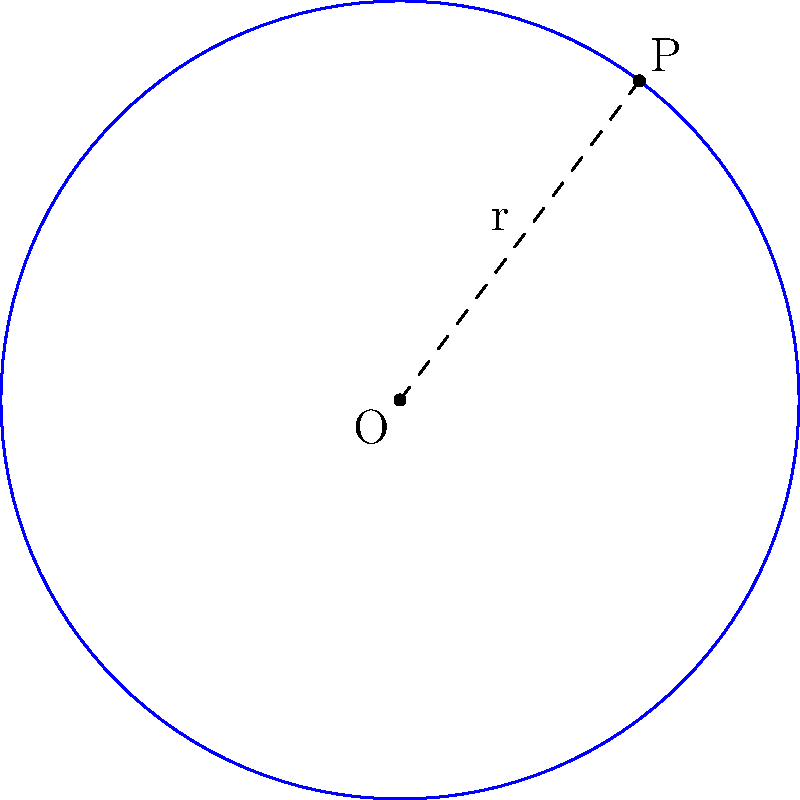Instead of wasting time watching TV series, consider this mathematical challenge: A circle has its center at point O(2,3) and passes through point P(5,7). Determine the equation of this circle. To find the equation of the circle, we'll follow these steps:

1) The general equation of a circle is $$(x-h)^2 + (y-k)^2 = r^2$$
   where (h,k) is the center and r is the radius.

2) We're given the center O(2,3), so h=2 and k=3.

3) To find r, we need to calculate the distance between O and P:
   $$r = \sqrt{(x_P-x_O)^2 + (y_P-y_O)^2}$$
   $$r = \sqrt{(5-2)^2 + (7-3)^2}$$
   $$r = \sqrt{3^2 + 4^2} = \sqrt{9 + 16} = \sqrt{25} = 5$$

4) Now we can substitute these values into the general equation:
   $$(x-2)^2 + (y-3)^2 = 5^2$$

5) Simplify:
   $$(x-2)^2 + (y-3)^2 = 25$$

This is the equation of the circle.
Answer: $(x-2)^2 + (y-3)^2 = 25$ 